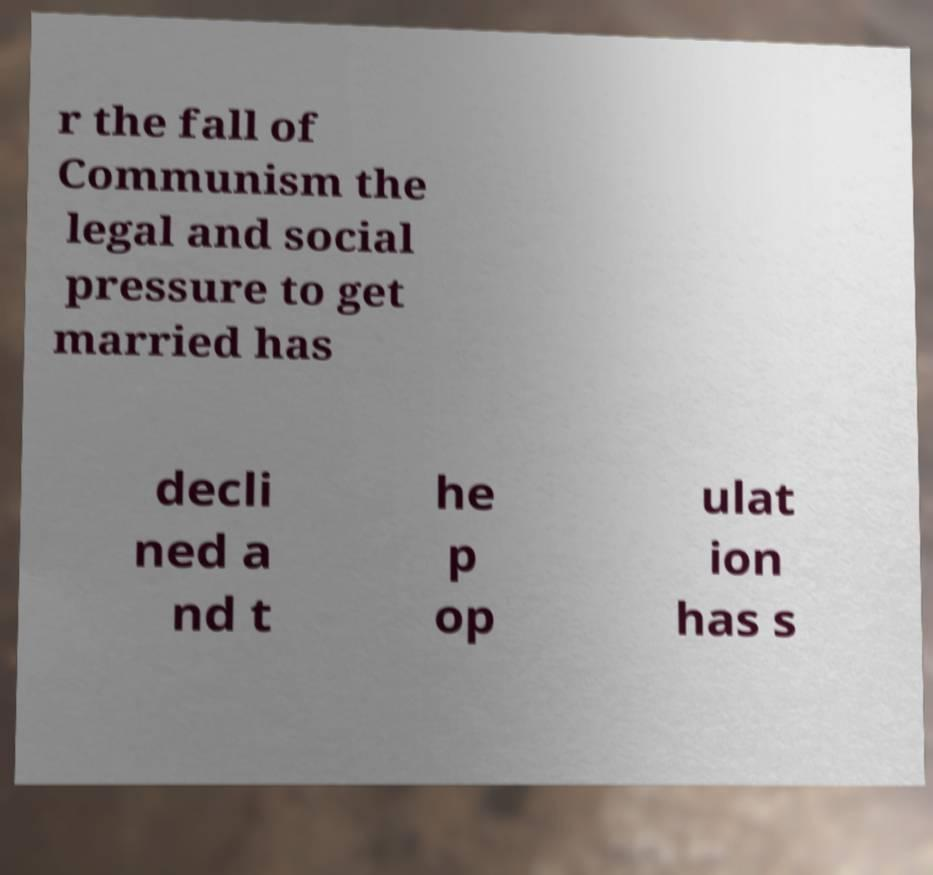What messages or text are displayed in this image? I need them in a readable, typed format. r the fall of Communism the legal and social pressure to get married has decli ned a nd t he p op ulat ion has s 